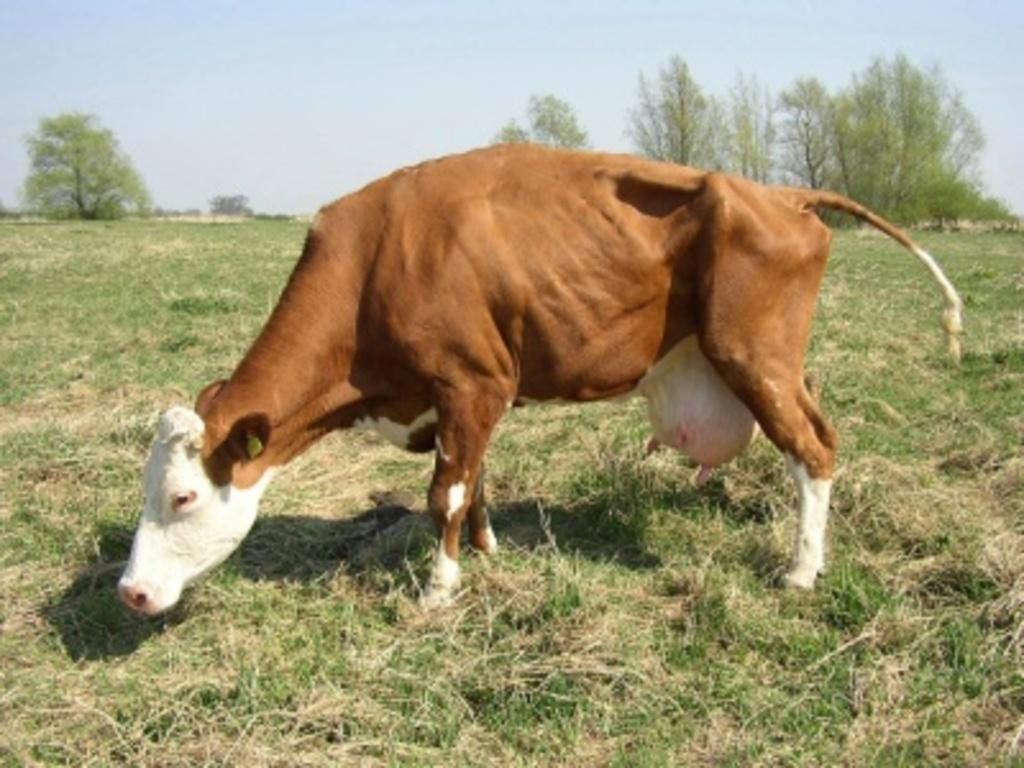What animal is present in the image? There is a cow in the image. Where is the cow located? The cow is on the grass. What can be seen in the background of the image? There are trees and the sky visible in the background of the image. What type of bread is the cow eating in the image? There is no bread present in the image, and the cow is not shown eating anything. 